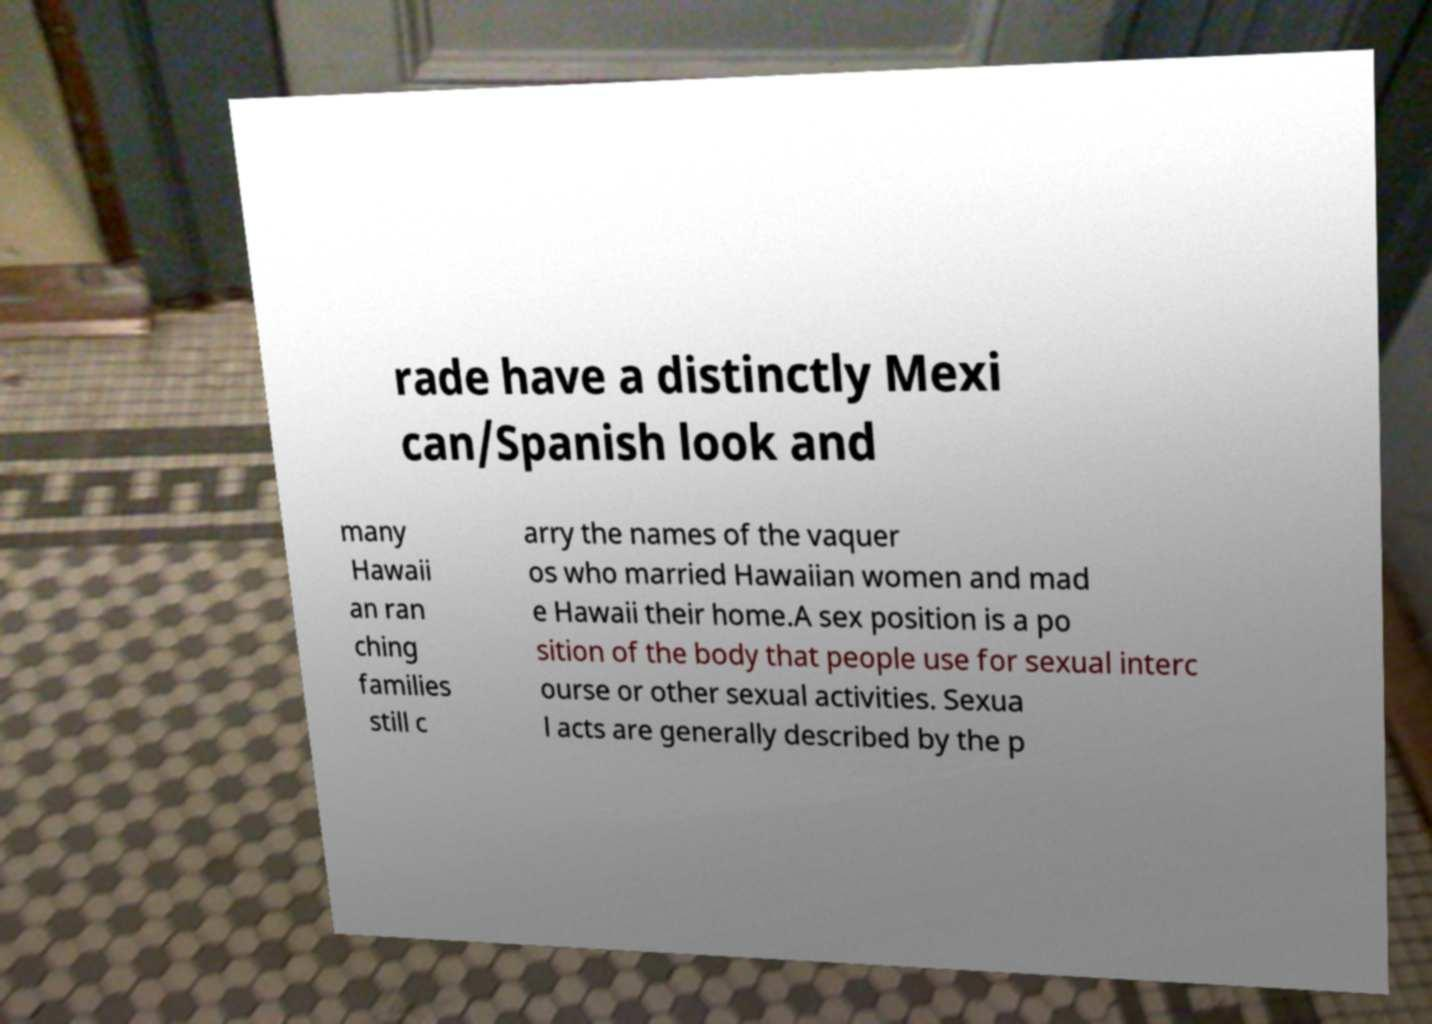Please identify and transcribe the text found in this image. rade have a distinctly Mexi can/Spanish look and many Hawaii an ran ching families still c arry the names of the vaquer os who married Hawaiian women and mad e Hawaii their home.A sex position is a po sition of the body that people use for sexual interc ourse or other sexual activities. Sexua l acts are generally described by the p 